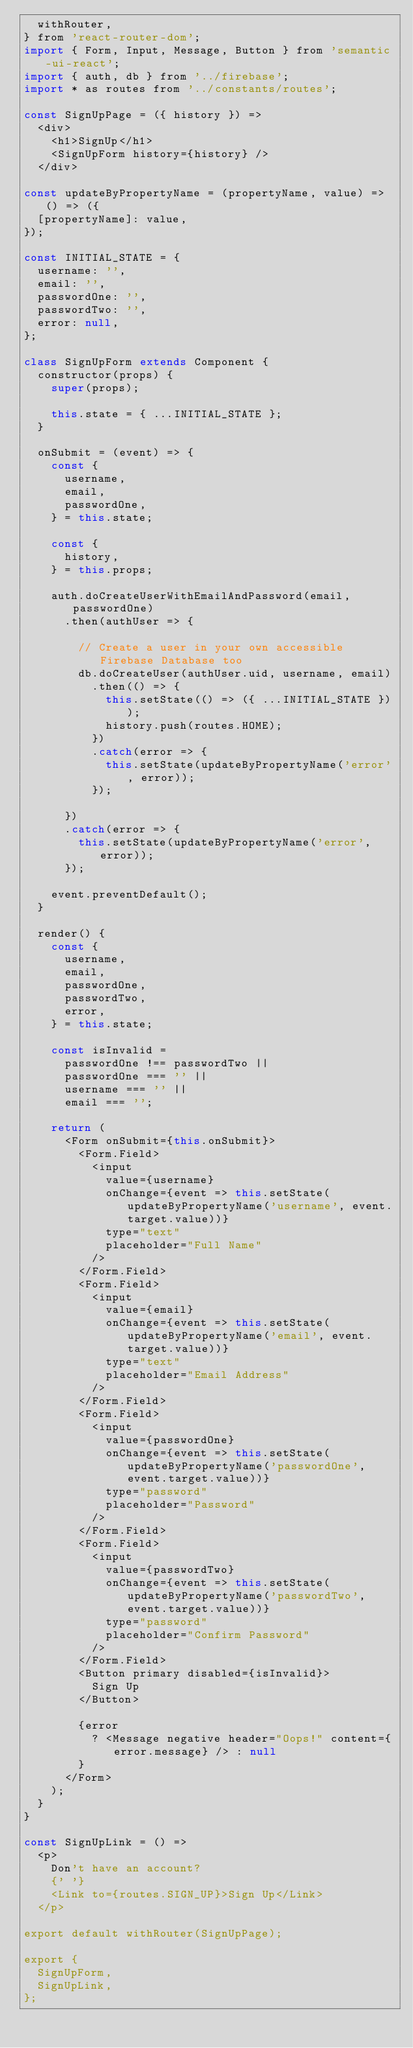<code> <loc_0><loc_0><loc_500><loc_500><_JavaScript_>  withRouter,
} from 'react-router-dom';
import { Form, Input, Message, Button } from 'semantic-ui-react';
import { auth, db } from '../firebase';
import * as routes from '../constants/routes';

const SignUpPage = ({ history }) =>
  <div>
    <h1>SignUp</h1>
    <SignUpForm history={history} />
  </div>

const updateByPropertyName = (propertyName, value) => () => ({
  [propertyName]: value,
});

const INITIAL_STATE = {
  username: '',
  email: '',
  passwordOne: '',
  passwordTwo: '',
  error: null,
};

class SignUpForm extends Component {
  constructor(props) {
    super(props);

    this.state = { ...INITIAL_STATE };
  }

  onSubmit = (event) => {
    const {
      username,
      email,
      passwordOne,
    } = this.state;

    const {
      history,
    } = this.props;

    auth.doCreateUserWithEmailAndPassword(email, passwordOne)
      .then(authUser => {

        // Create a user in your own accessible Firebase Database too
        db.doCreateUser(authUser.uid, username, email)
          .then(() => {
            this.setState(() => ({ ...INITIAL_STATE }));
            history.push(routes.HOME);
          })
          .catch(error => {
            this.setState(updateByPropertyName('error', error));
          });

      })
      .catch(error => {
        this.setState(updateByPropertyName('error', error));
      });

    event.preventDefault();
  }

  render() {
    const {
      username,
      email,
      passwordOne,
      passwordTwo,
      error,
    } = this.state;

    const isInvalid =
      passwordOne !== passwordTwo ||
      passwordOne === '' ||
      username === '' ||
      email === '';

    return (
      <Form onSubmit={this.onSubmit}>
        <Form.Field>
          <input
            value={username}
            onChange={event => this.setState(updateByPropertyName('username', event.target.value))}
            type="text"
            placeholder="Full Name"
          />
        </Form.Field>
        <Form.Field>
          <input
            value={email}
            onChange={event => this.setState(updateByPropertyName('email', event.target.value))}
            type="text"
            placeholder="Email Address"
          />
        </Form.Field>
        <Form.Field>
          <input
            value={passwordOne}
            onChange={event => this.setState(updateByPropertyName('passwordOne', event.target.value))}
            type="password"
            placeholder="Password"
          />
        </Form.Field>
        <Form.Field>
          <input
            value={passwordTwo}
            onChange={event => this.setState(updateByPropertyName('passwordTwo', event.target.value))}
            type="password"
            placeholder="Confirm Password"
          />
        </Form.Field>
        <Button primary disabled={isInvalid}>
          Sign Up
        </Button>

        {error
          ? <Message negative header="Oops!" content={error.message} /> : null
        }
      </Form>
    );
  }
}

const SignUpLink = () =>
  <p>
    Don't have an account?
    {' '}
    <Link to={routes.SIGN_UP}>Sign Up</Link>
  </p>

export default withRouter(SignUpPage);

export {
  SignUpForm,
  SignUpLink,
};</code> 